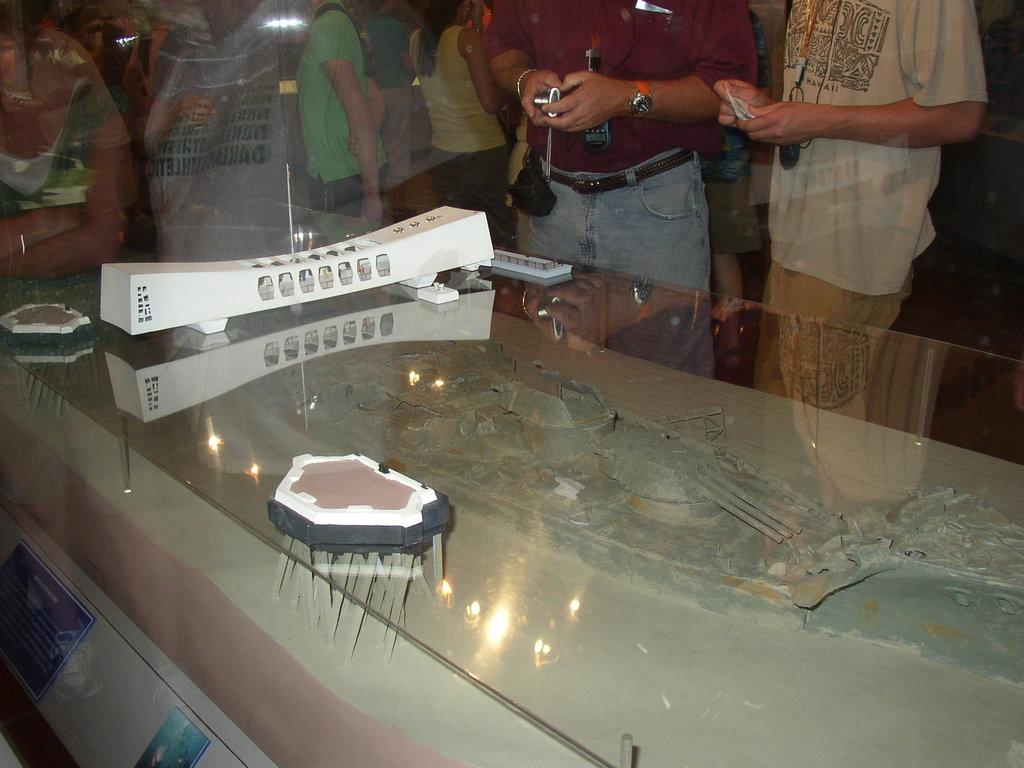What is the primary surface visible in the image? There are objects on a glass surface in the image. Can you describe the people in the background? There are persons standing in the background of the image. What type of division is taking place in the image? There is no division taking place in the image; it does not involve any separation or categorization. 